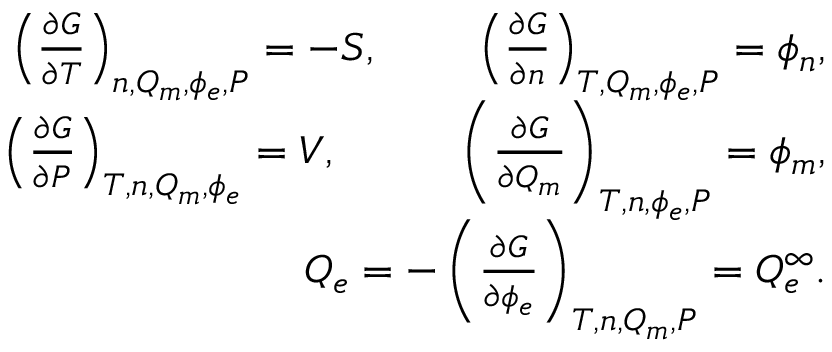<formula> <loc_0><loc_0><loc_500><loc_500>\begin{array} { r l r } & { \left ( \frac { \partial G } { \partial T } \right ) _ { n , Q _ { m } , \phi _ { e } , P } = - S , \, \left ( \frac { \partial G } { \partial n } \right ) _ { T , Q _ { m } , \phi _ { e } , P } = \phi _ { n } , } \\ & { \left ( \frac { \partial G } { \partial P } \right ) _ { T , n , Q _ { m } , \phi _ { e } } = V , \, \left ( \frac { \partial G } { \partial Q _ { m } } \right ) _ { T , n , \phi _ { e } , P } = \phi _ { m } , } \\ & { \, Q _ { e } = - \left ( \frac { \partial G } { \partial \phi _ { e } } \right ) _ { T , n , Q _ { m } , P } = Q _ { e } ^ { \infty } . } \end{array}</formula> 